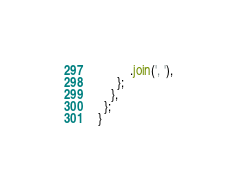Convert code to text. <code><loc_0><loc_0><loc_500><loc_500><_JavaScript_>          .join(', '),
      };
    },
  };
}
</code> 